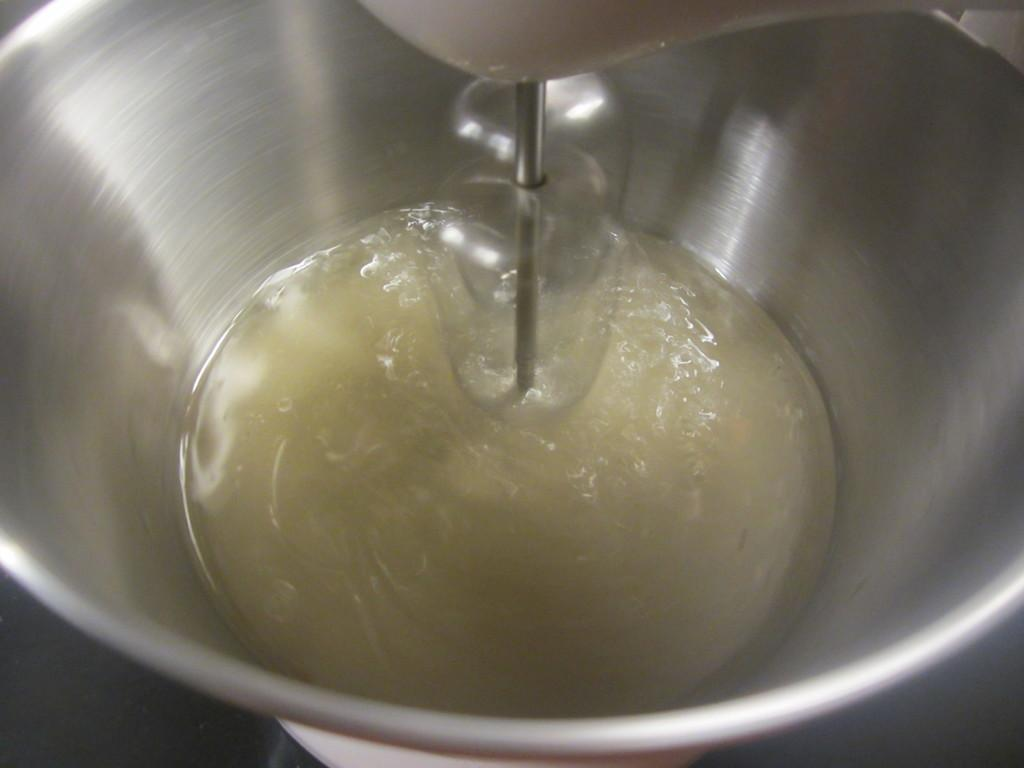What is located in the center of the image? There is a bowl in the middle of the image. What can be found inside the bowl? There is an unspecified object or substance inside the bowl. How does the father feel about the person in the image? There is no father or person present in the image, so it is not possible to determine how the father feels about the person. 